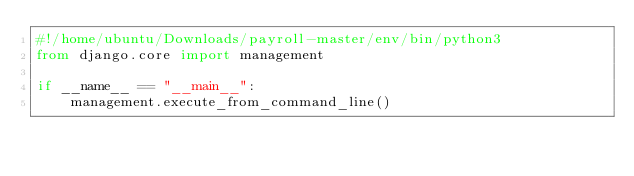Convert code to text. <code><loc_0><loc_0><loc_500><loc_500><_Python_>#!/home/ubuntu/Downloads/payroll-master/env/bin/python3
from django.core import management

if __name__ == "__main__":
    management.execute_from_command_line()
</code> 